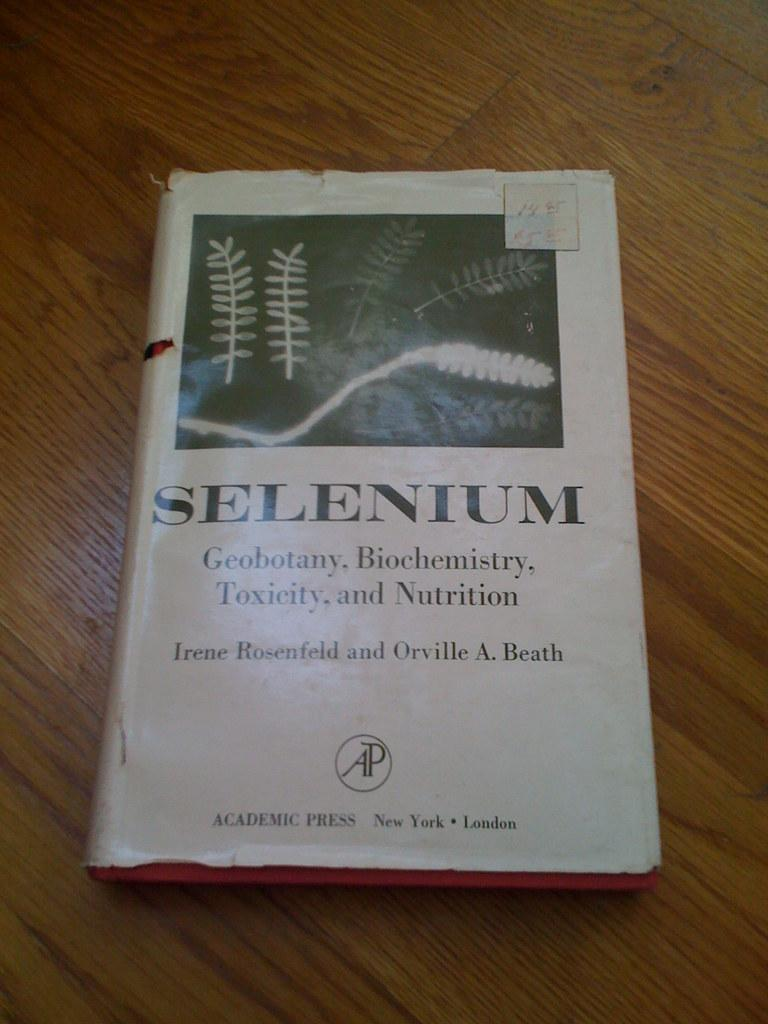<image>
Summarize the visual content of the image. A book titled Selenium laying on a laminate table. 